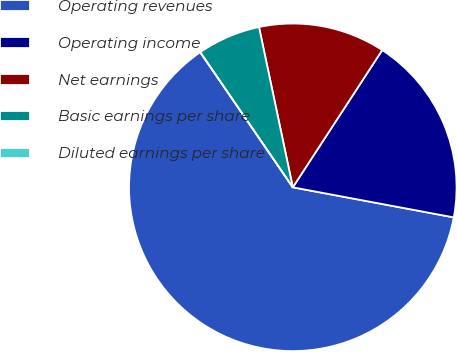Convert chart to OTSL. <chart><loc_0><loc_0><loc_500><loc_500><pie_chart><fcel>Operating revenues<fcel>Operating income<fcel>Net earnings<fcel>Basic earnings per share<fcel>Diluted earnings per share<nl><fcel>62.5%<fcel>18.75%<fcel>12.5%<fcel>6.25%<fcel>0.0%<nl></chart> 